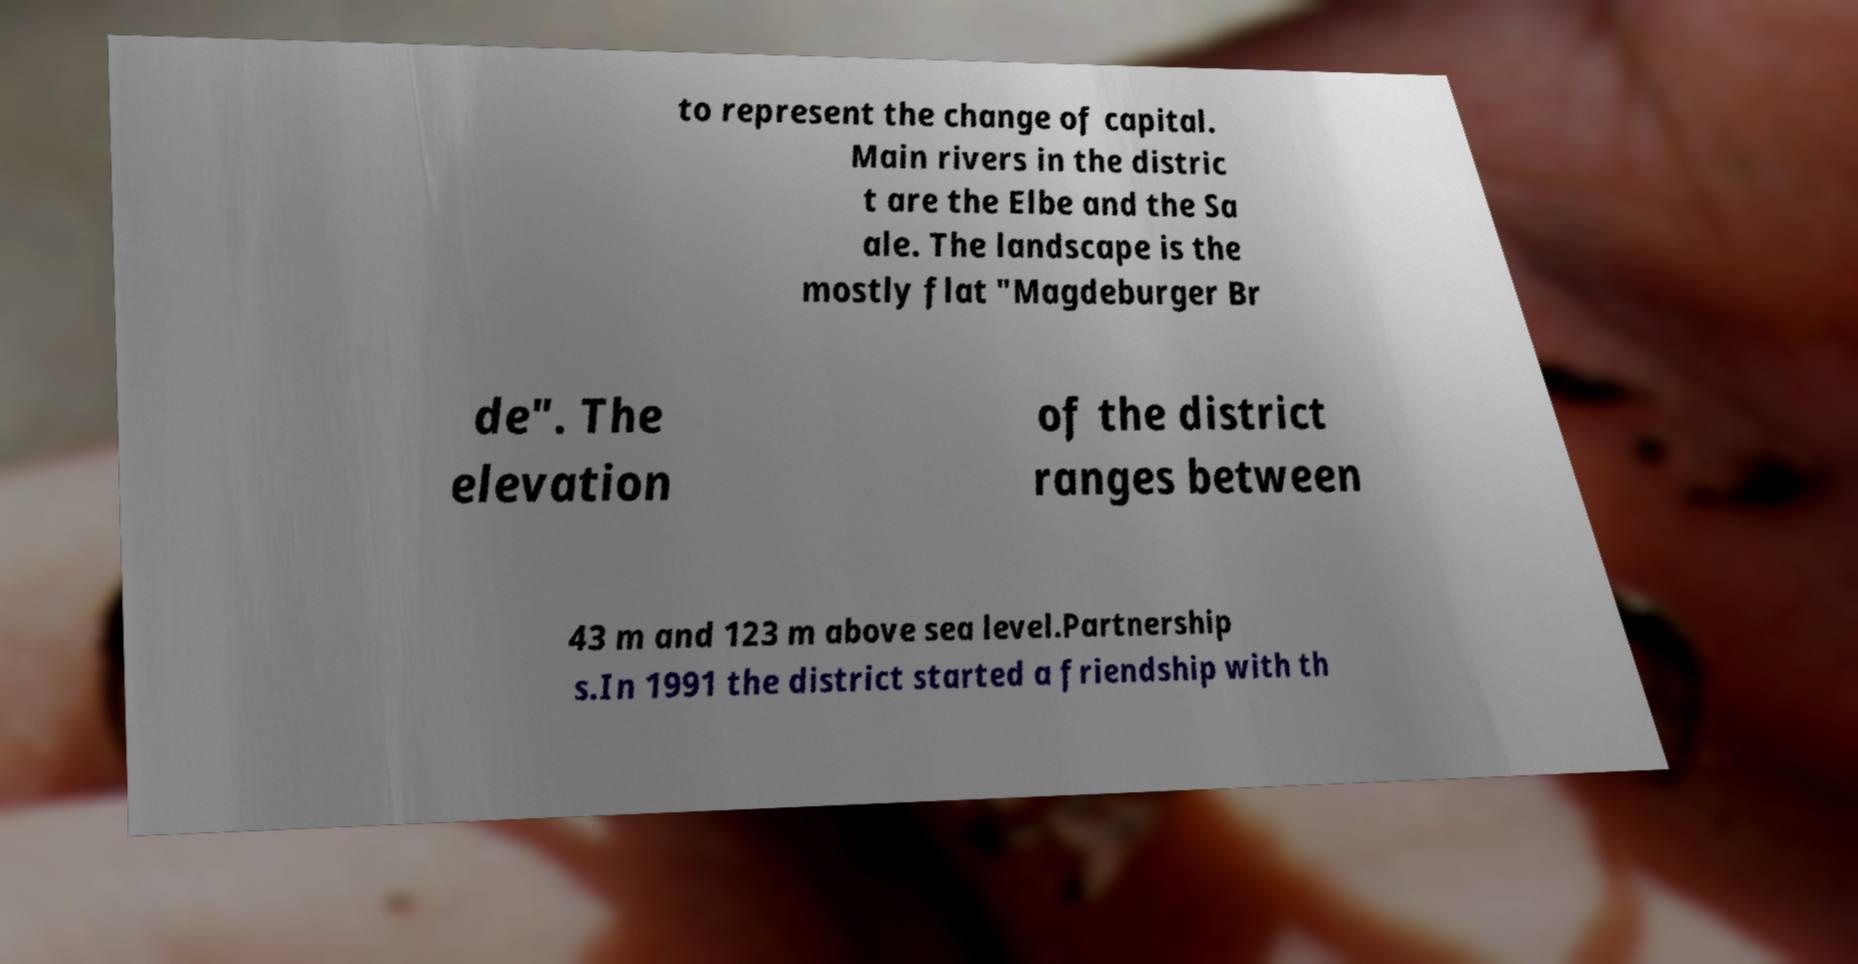Could you extract and type out the text from this image? to represent the change of capital. Main rivers in the distric t are the Elbe and the Sa ale. The landscape is the mostly flat "Magdeburger Br de". The elevation of the district ranges between 43 m and 123 m above sea level.Partnership s.In 1991 the district started a friendship with th 